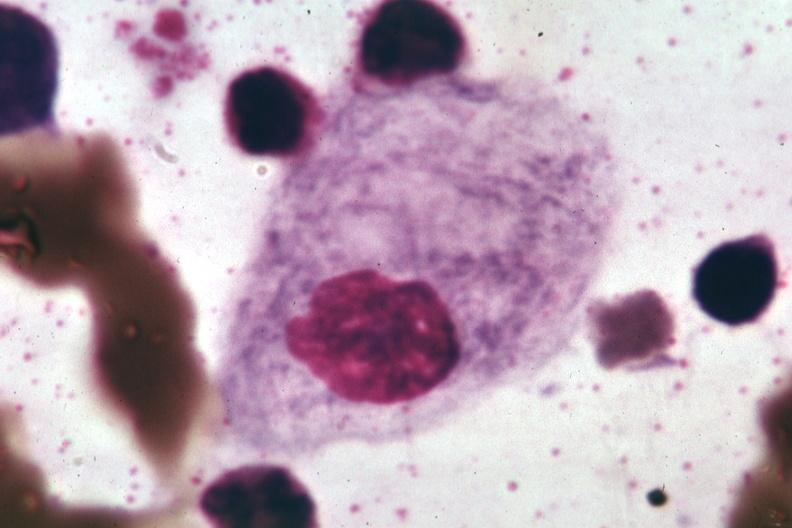what is present?
Answer the question using a single word or phrase. Gaucher cell 